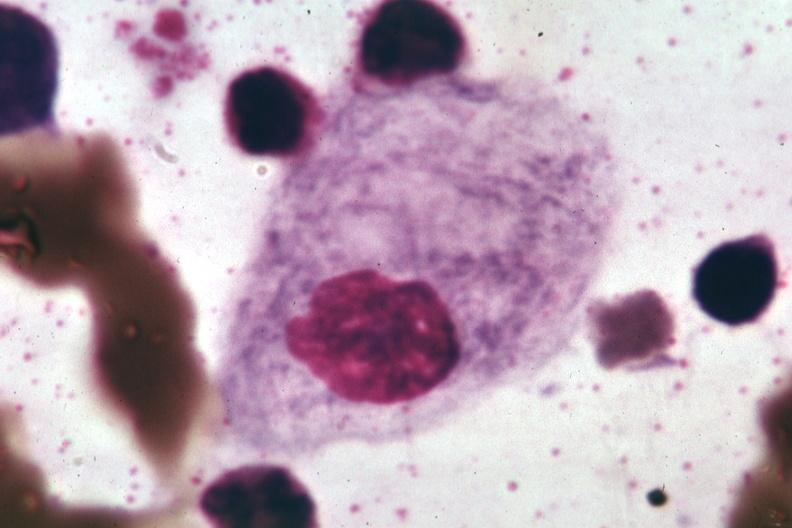what is present?
Answer the question using a single word or phrase. Gaucher cell 